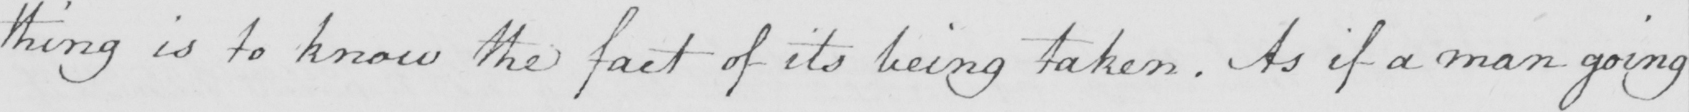Please transcribe the handwritten text in this image. thing is to know the fact of its being taken . As if a man going 